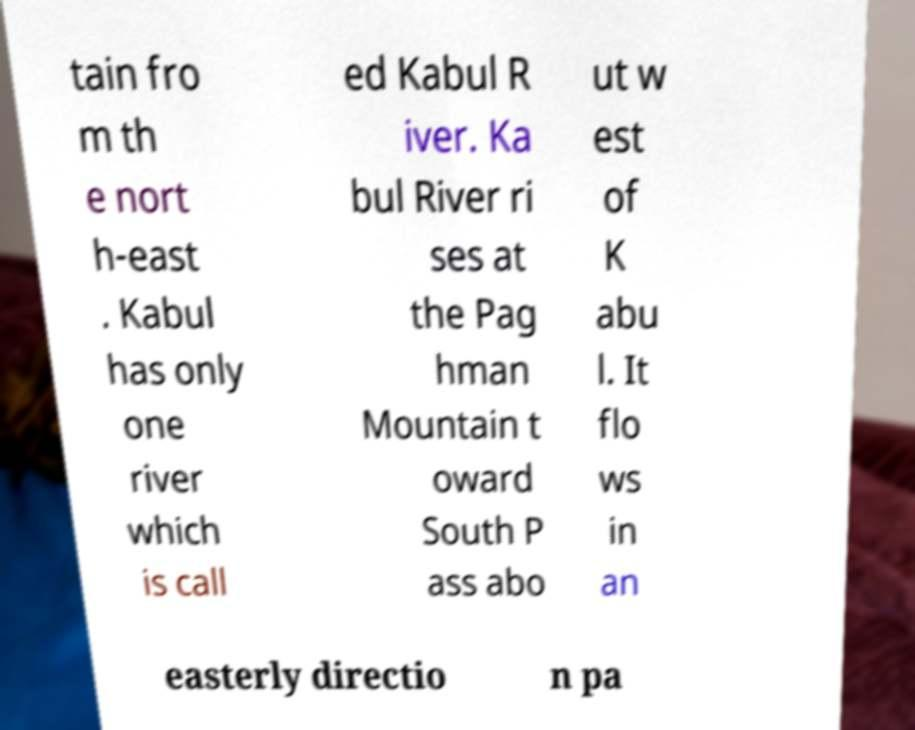Can you read and provide the text displayed in the image?This photo seems to have some interesting text. Can you extract and type it out for me? tain fro m th e nort h-east . Kabul has only one river which is call ed Kabul R iver. Ka bul River ri ses at the Pag hman Mountain t oward South P ass abo ut w est of K abu l. It flo ws in an easterly directio n pa 